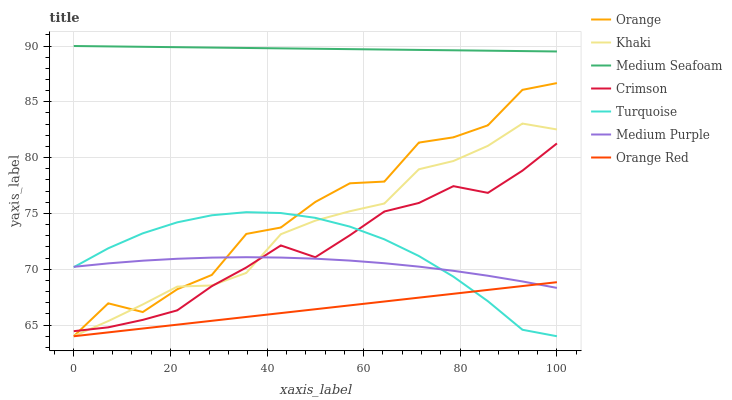Does Orange Red have the minimum area under the curve?
Answer yes or no. Yes. Does Medium Seafoam have the maximum area under the curve?
Answer yes or no. Yes. Does Khaki have the minimum area under the curve?
Answer yes or no. No. Does Khaki have the maximum area under the curve?
Answer yes or no. No. Is Orange Red the smoothest?
Answer yes or no. Yes. Is Orange the roughest?
Answer yes or no. Yes. Is Khaki the smoothest?
Answer yes or no. No. Is Khaki the roughest?
Answer yes or no. No. Does Turquoise have the lowest value?
Answer yes or no. Yes. Does Medium Purple have the lowest value?
Answer yes or no. No. Does Medium Seafoam have the highest value?
Answer yes or no. Yes. Does Khaki have the highest value?
Answer yes or no. No. Is Orange Red less than Medium Seafoam?
Answer yes or no. Yes. Is Medium Seafoam greater than Khaki?
Answer yes or no. Yes. Does Khaki intersect Medium Purple?
Answer yes or no. Yes. Is Khaki less than Medium Purple?
Answer yes or no. No. Is Khaki greater than Medium Purple?
Answer yes or no. No. Does Orange Red intersect Medium Seafoam?
Answer yes or no. No. 